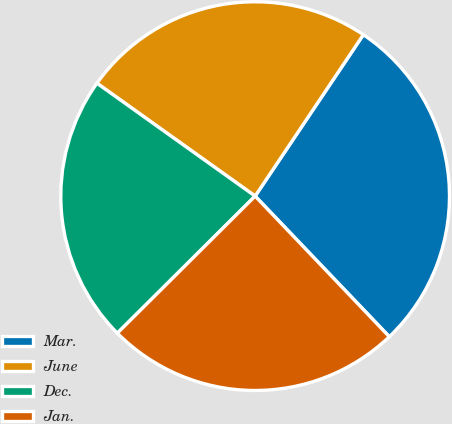<chart> <loc_0><loc_0><loc_500><loc_500><pie_chart><fcel>Mar.<fcel>June<fcel>Dec.<fcel>Jan.<nl><fcel>28.47%<fcel>24.53%<fcel>22.32%<fcel>24.67%<nl></chart> 